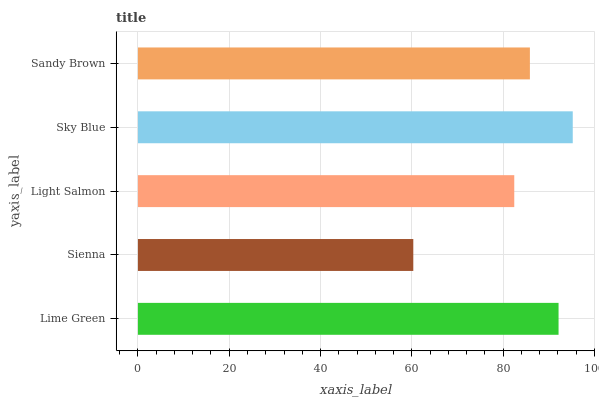Is Sienna the minimum?
Answer yes or no. Yes. Is Sky Blue the maximum?
Answer yes or no. Yes. Is Light Salmon the minimum?
Answer yes or no. No. Is Light Salmon the maximum?
Answer yes or no. No. Is Light Salmon greater than Sienna?
Answer yes or no. Yes. Is Sienna less than Light Salmon?
Answer yes or no. Yes. Is Sienna greater than Light Salmon?
Answer yes or no. No. Is Light Salmon less than Sienna?
Answer yes or no. No. Is Sandy Brown the high median?
Answer yes or no. Yes. Is Sandy Brown the low median?
Answer yes or no. Yes. Is Sky Blue the high median?
Answer yes or no. No. Is Sky Blue the low median?
Answer yes or no. No. 